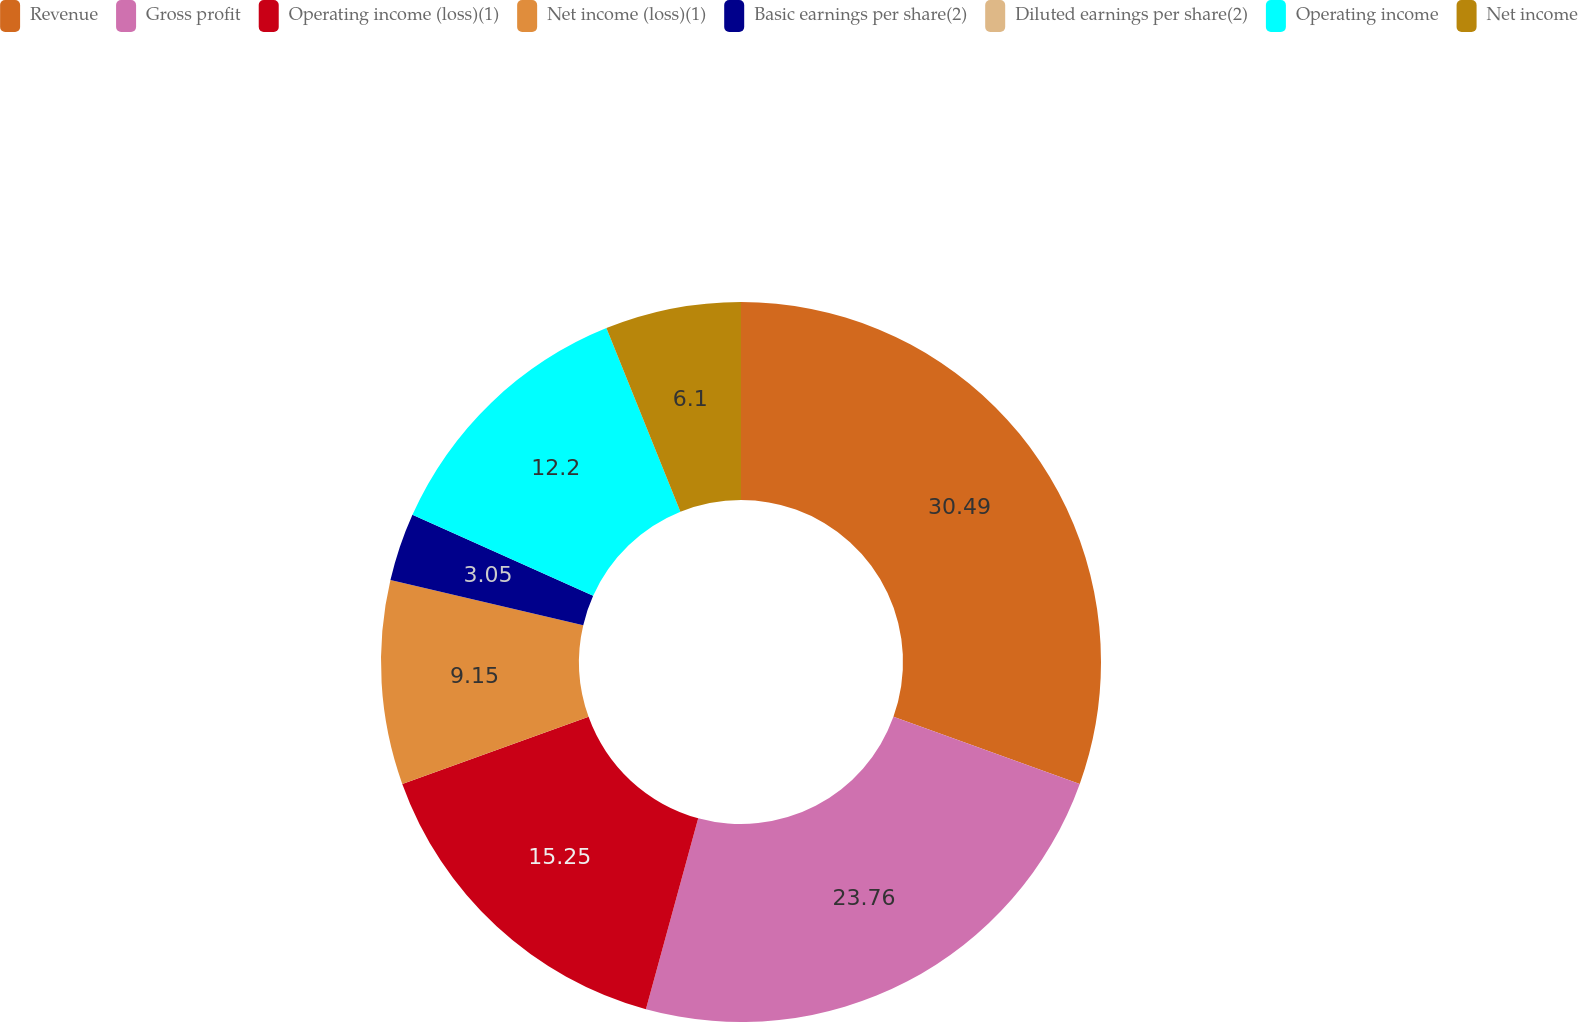Convert chart to OTSL. <chart><loc_0><loc_0><loc_500><loc_500><pie_chart><fcel>Revenue<fcel>Gross profit<fcel>Operating income (loss)(1)<fcel>Net income (loss)(1)<fcel>Basic earnings per share(2)<fcel>Diluted earnings per share(2)<fcel>Operating income<fcel>Net income<nl><fcel>30.5%<fcel>23.76%<fcel>15.25%<fcel>9.15%<fcel>3.05%<fcel>0.0%<fcel>12.2%<fcel>6.1%<nl></chart> 